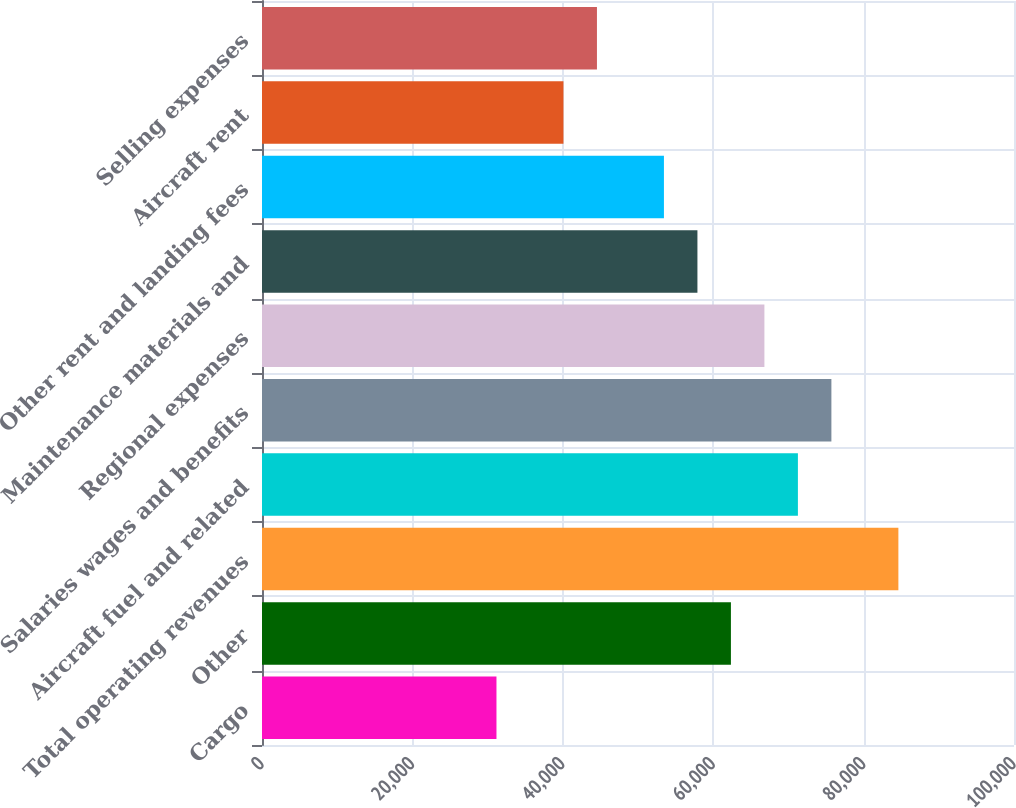Convert chart to OTSL. <chart><loc_0><loc_0><loc_500><loc_500><bar_chart><fcel>Cargo<fcel>Other<fcel>Total operating revenues<fcel>Aircraft fuel and related<fcel>Salaries wages and benefits<fcel>Regional expenses<fcel>Maintenance materials and<fcel>Other rent and landing fees<fcel>Aircraft rent<fcel>Selling expenses<nl><fcel>31179.6<fcel>62356.2<fcel>84625.2<fcel>71263.8<fcel>75717.6<fcel>66810<fcel>57902.4<fcel>53448.6<fcel>40087.2<fcel>44541<nl></chart> 